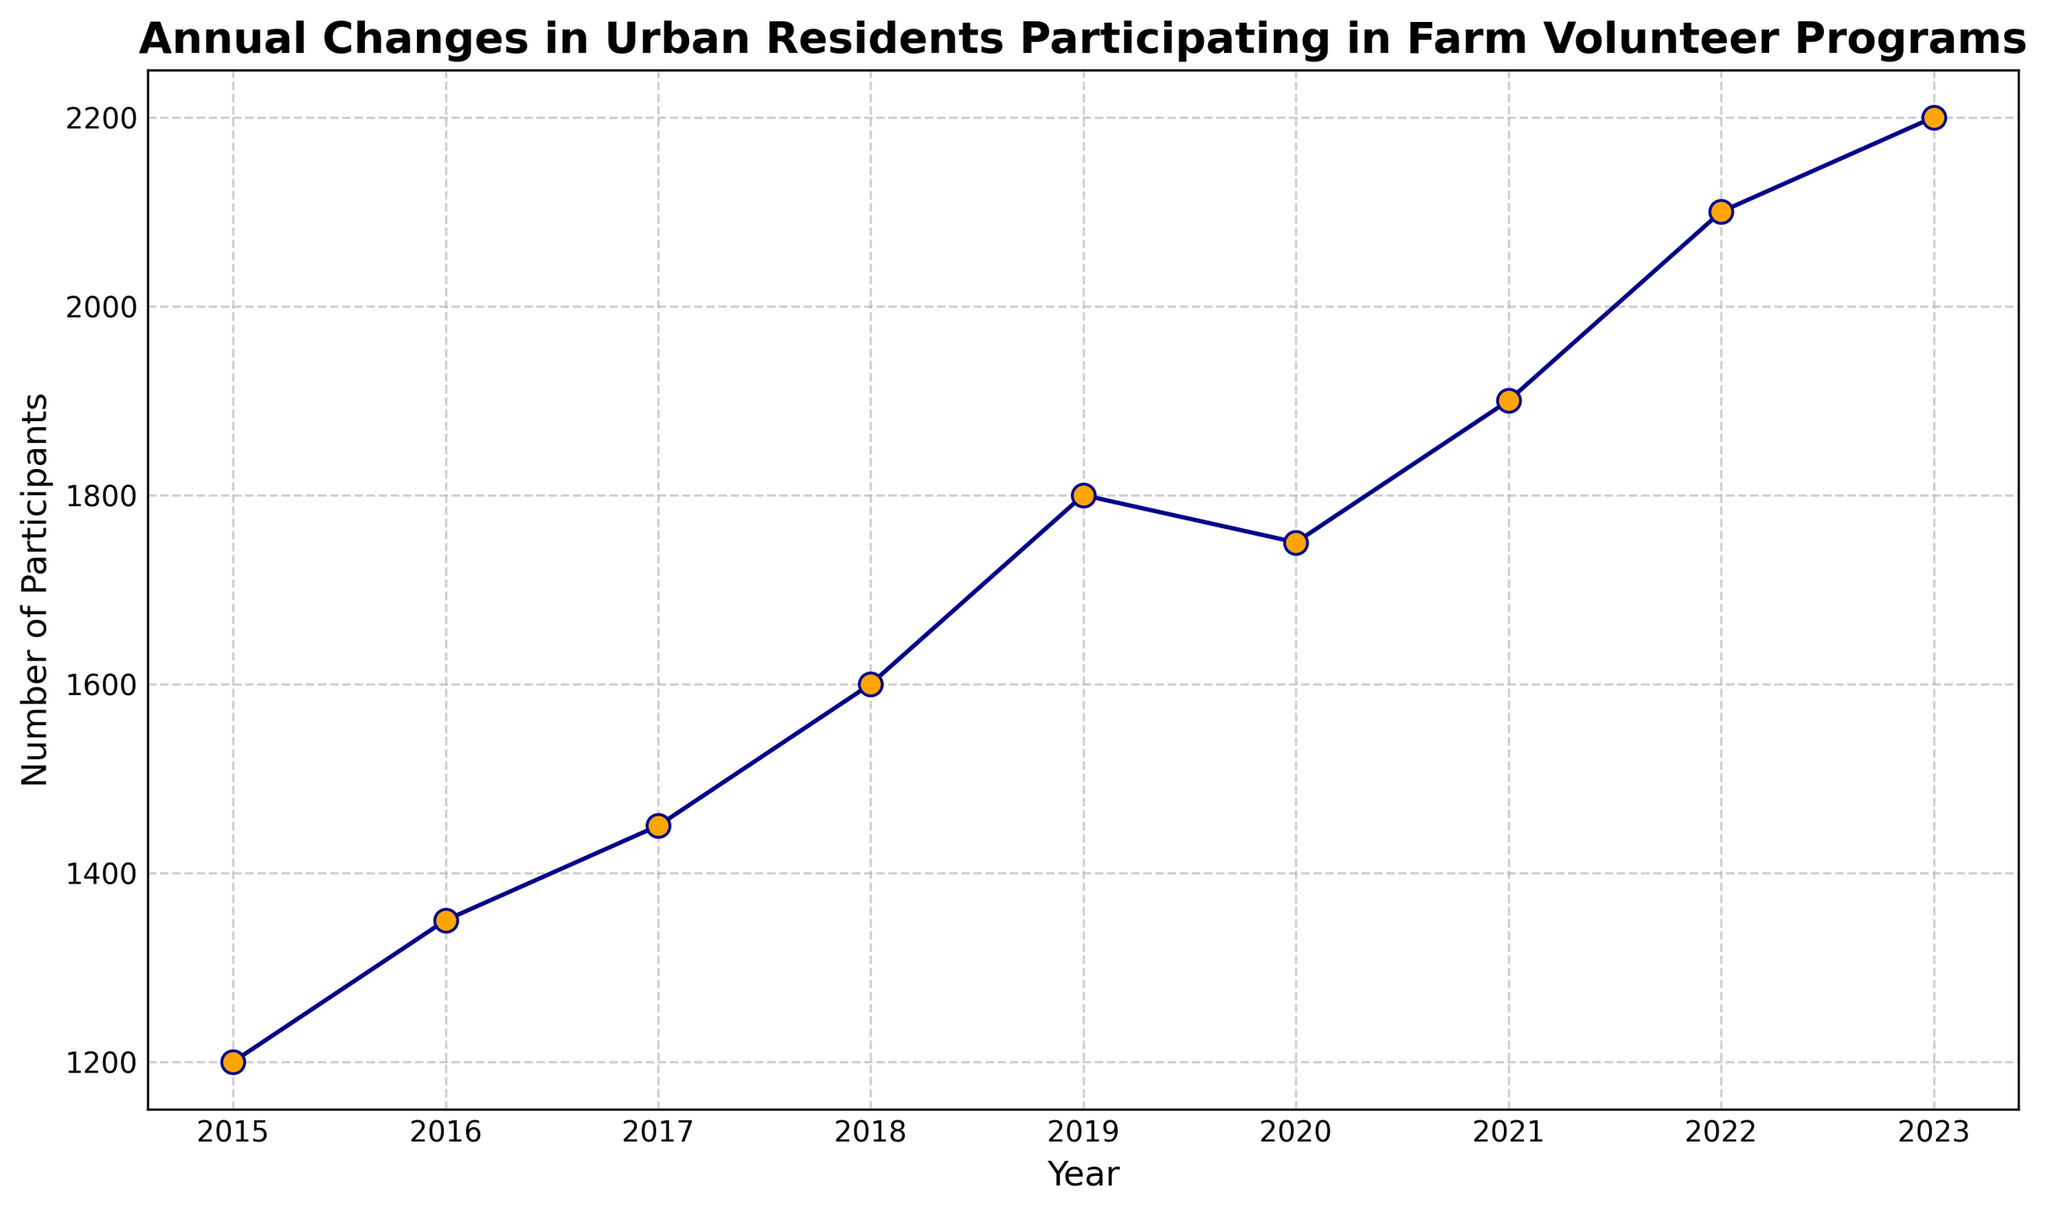What's the overall trend in the number of participants from 2015 to 2023? The overall trend can be identified by observing whether the line mostly goes up or down. From 2015 to 2023, the line generally ascends with minor decreases, indicating an increasing trend.
Answer: Increasing trend In which year did the number of participants first exceed 2000? Look for the first year where the y-axis value is over 2000. In the chart, this occurs in 2022.
Answer: 2022 What is the largest year-over-year increase in the number of participants? Compare each year to the following year and identify the largest difference. The largest increase is from 2019 to 2020 (300 participants).
Answer: 300 participants How many more participants were there in 2023 compared to 2015? Subtract the number of participants in 2015 from the number of participants in 2023: 2200 - 1200 = 1000.
Answer: 1000 What is the average number of participants from 2015 to 2023? Sum the total participants from all years and divide by the number of years (9): (1200 + 1350 + 1450 + 1600 + 1800 + 1750 + 1900 + 2100 + 2200)/9 ≈ 1706
Answer: 1706 During which year did the number of participants decrease compared to the previous year? Identify the year where the line drops compared to the previous year. This occurred in 2020 as the number decreased from 1800 to 1750.
Answer: 2020 What is the difference between the number of participants in the year with the highest and lowest values? Identify the highest (2200 in 2023) and lowest (1200 in 2015) values, and subtract the lowest from the highest: 2200 - 1200 = 1000.
Answer: 1000 In which years did the number of participants increase by 200 or more compared to the previous year? Check the yearly increments that are 200 or more. Such increments occurred between 2018 and 2019 (200), and 2021 and 2022 (200).
Answer: 2019, 2022 How many participants were there in total across all shown years? Add the number of participants from all years to get the total: 1200 + 1350 + 1450 + 1600 + 1800 + 1750 + 1900 + 2100 + 2200 = 15350.
Answer: 15350 Which year shows the highest number of participants? The highest point on the y-axis corresponds to the year 2023 with 2200 participants.
Answer: 2023 